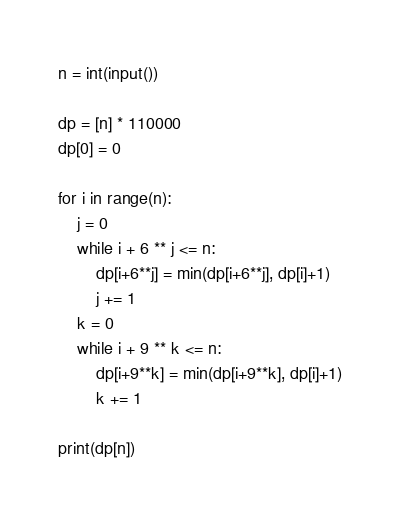Convert code to text. <code><loc_0><loc_0><loc_500><loc_500><_Python_>n = int(input())

dp = [n] * 110000
dp[0] = 0

for i in range(n):
    j = 0
    while i + 6 ** j <= n:
        dp[i+6**j] = min(dp[i+6**j], dp[i]+1)
        j += 1
    k = 0
    while i + 9 ** k <= n:
        dp[i+9**k] = min(dp[i+9**k], dp[i]+1)
        k += 1

print(dp[n])</code> 